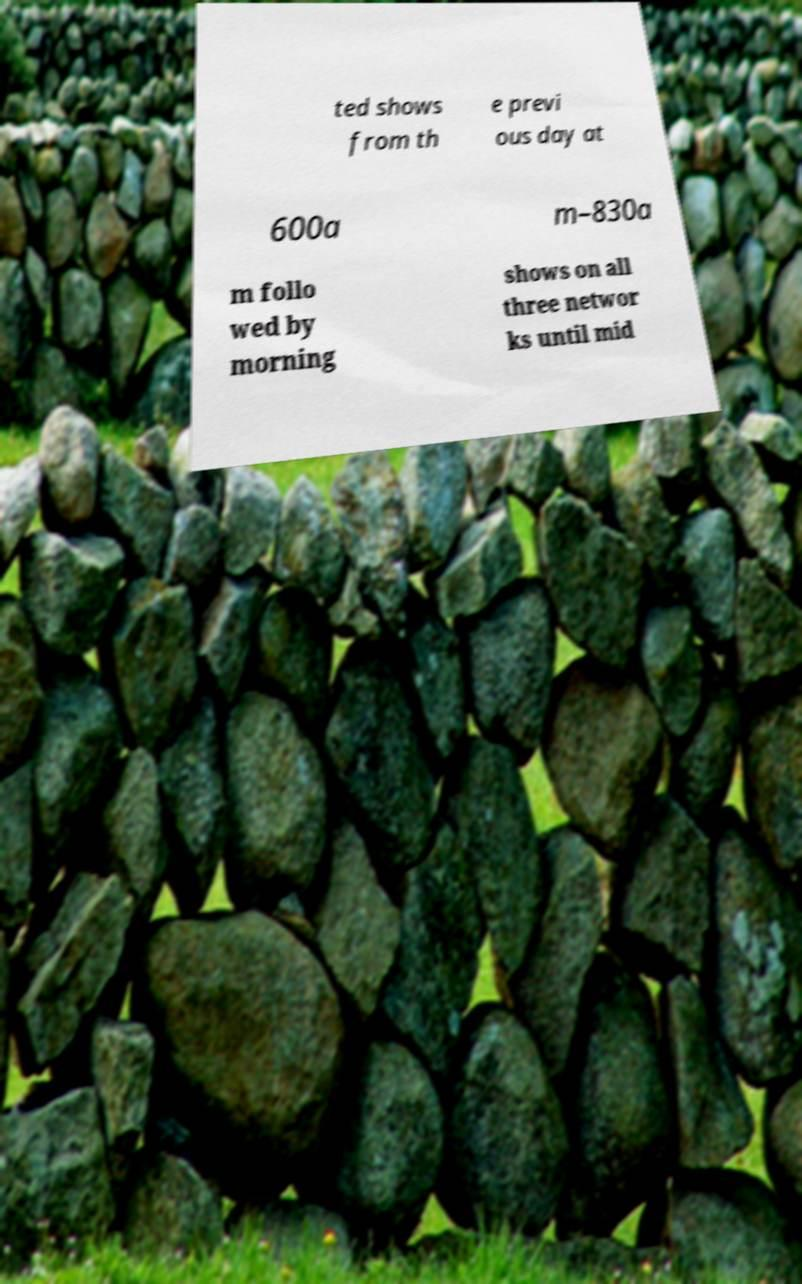Please read and relay the text visible in this image. What does it say? ted shows from th e previ ous day at 600a m–830a m follo wed by morning shows on all three networ ks until mid 